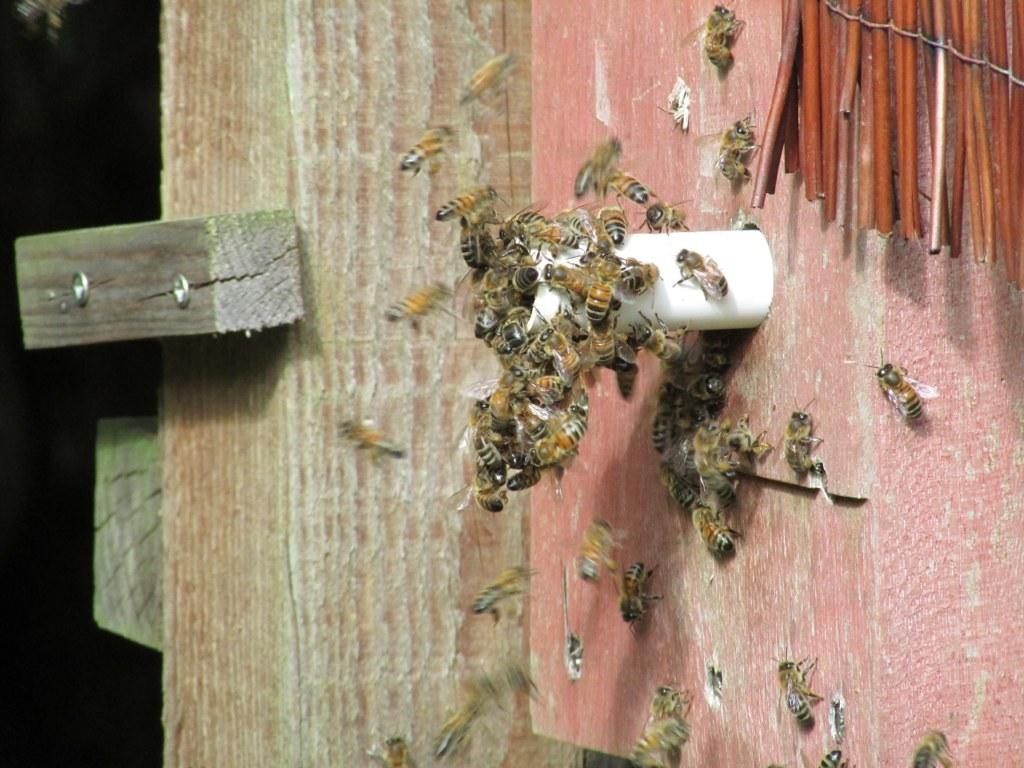What type of insects are present in the image? There are honey bees in the image. Where are the honey bees located? The honey bees are on a wooden surface. What other object can be seen in the image? There is a pipe in the image. What type of bread is being served during the recess in the image? There is no recess or bread present in the image; it features honey bees on a wooden surface and a pipe. 